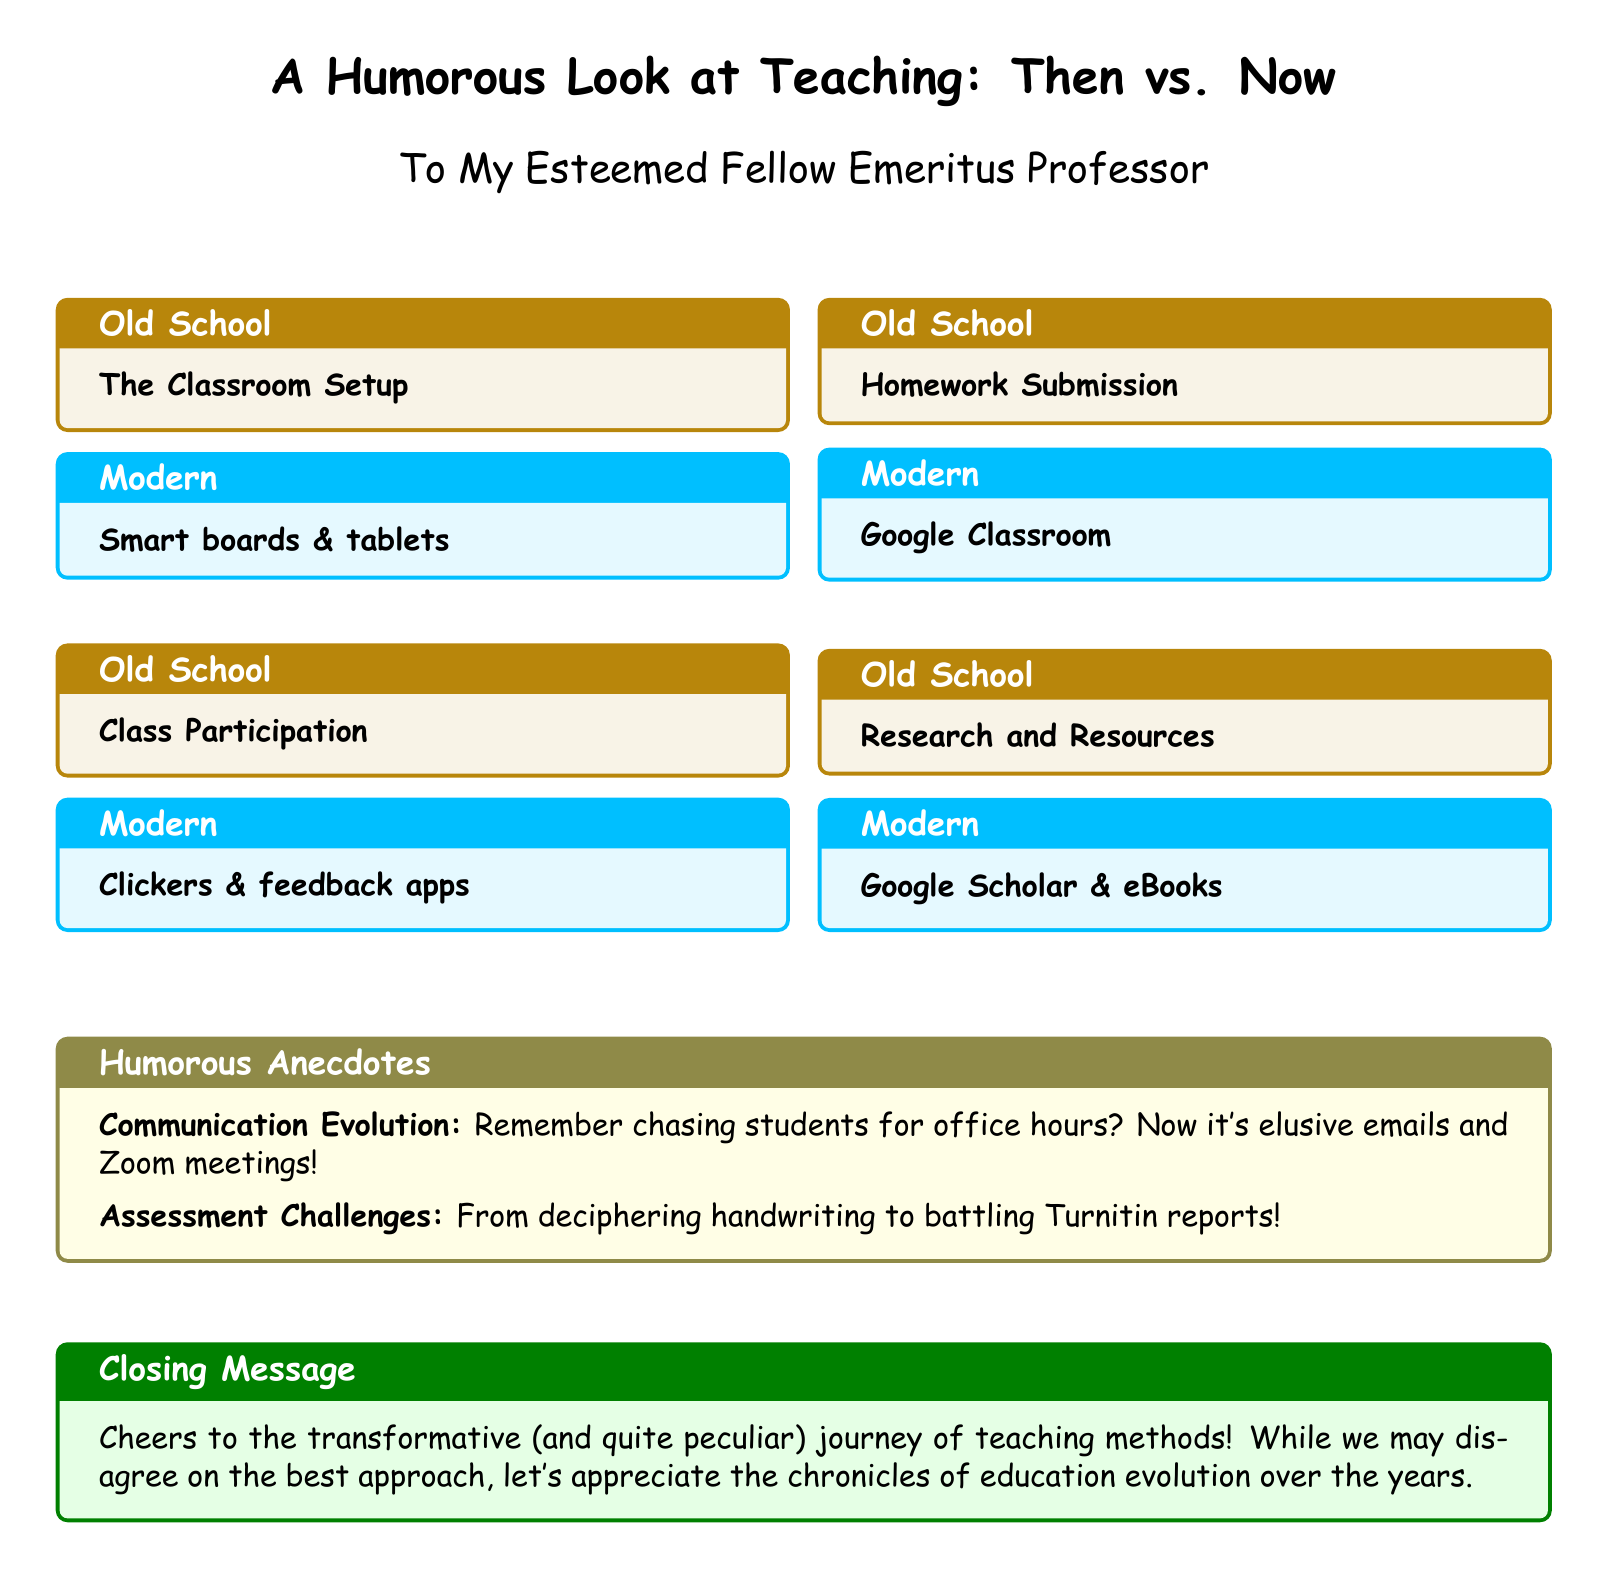What is the document's title? The title of the document is displayed prominently at the top, indicating the theme of the card.
Answer: A Humorous Look at Teaching: Then vs. Now Who is the card addressed to? The card includes a greeting that specifies the intended recipient.
Answer: My Esteemed Fellow Emeritus Professor What are two examples of 'Old School' classroom setups? The document lists different aspects of teaching under 'Old School,' including classroom setups.
Answer: The Classroom Setup, Class Participation What type of technology is mentioned under 'Modern' teaching? The document highlights various modern tools and methods compared to old ones.
Answer: Smart boards & tablets What humorous anecdote relates to communication? The document provides a humorous commentary on how communication methods have changed in teaching.
Answer: Remember chasing students for office hours? Now it's elusive emails and Zoom meetings! How many humorous anecdotes are included in the document? The document specifies that there are two humorous anecdotes presented.
Answer: Two What does the 'Closing Message' acknowledge about teaching methods? The final box summarizes the appreciation of the evolution of teaching methods over time.
Answer: Cheers to the transformative (and quite peculiar) journey of teaching methods! Which color is used for the 'Modern' teaching boxes? The document uses specific colors to differentiate between old and modern teaching techniques.
Answer: A shade of blue (modern) What is the primary theme of this greeting card? The overall theme can be deduced from the title and content, which contrasts teaching methods.
Answer: Humor in teaching evolution 